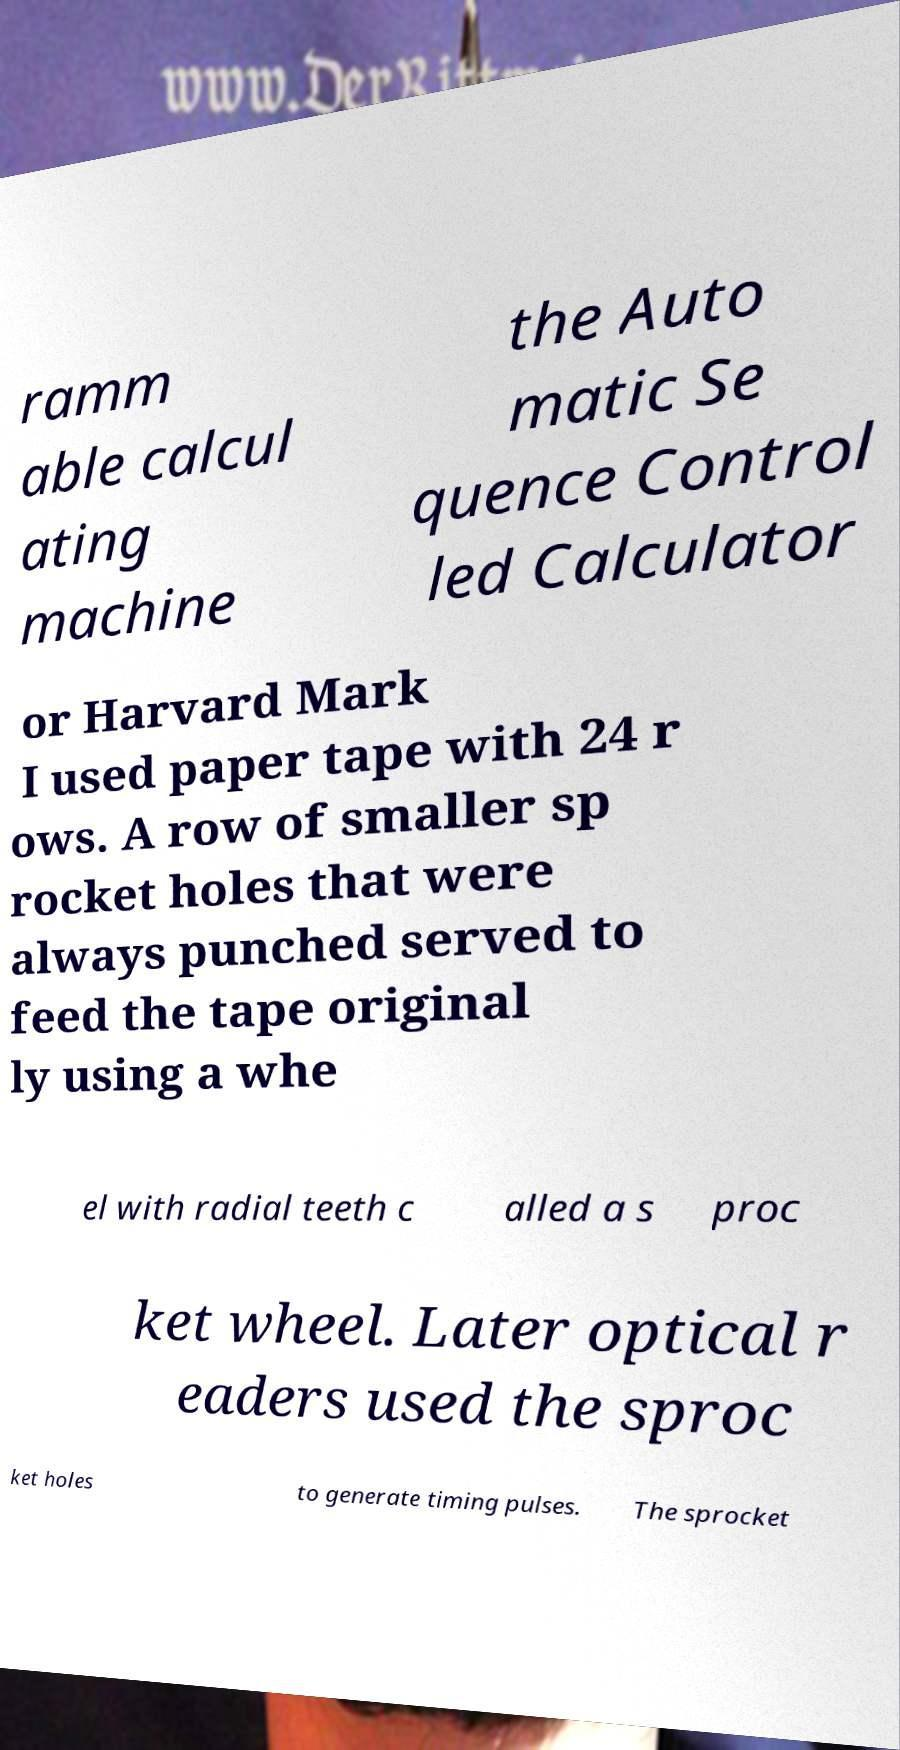What messages or text are displayed in this image? I need them in a readable, typed format. ramm able calcul ating machine the Auto matic Se quence Control led Calculator or Harvard Mark I used paper tape with 24 r ows. A row of smaller sp rocket holes that were always punched served to feed the tape original ly using a whe el with radial teeth c alled a s proc ket wheel. Later optical r eaders used the sproc ket holes to generate timing pulses. The sprocket 